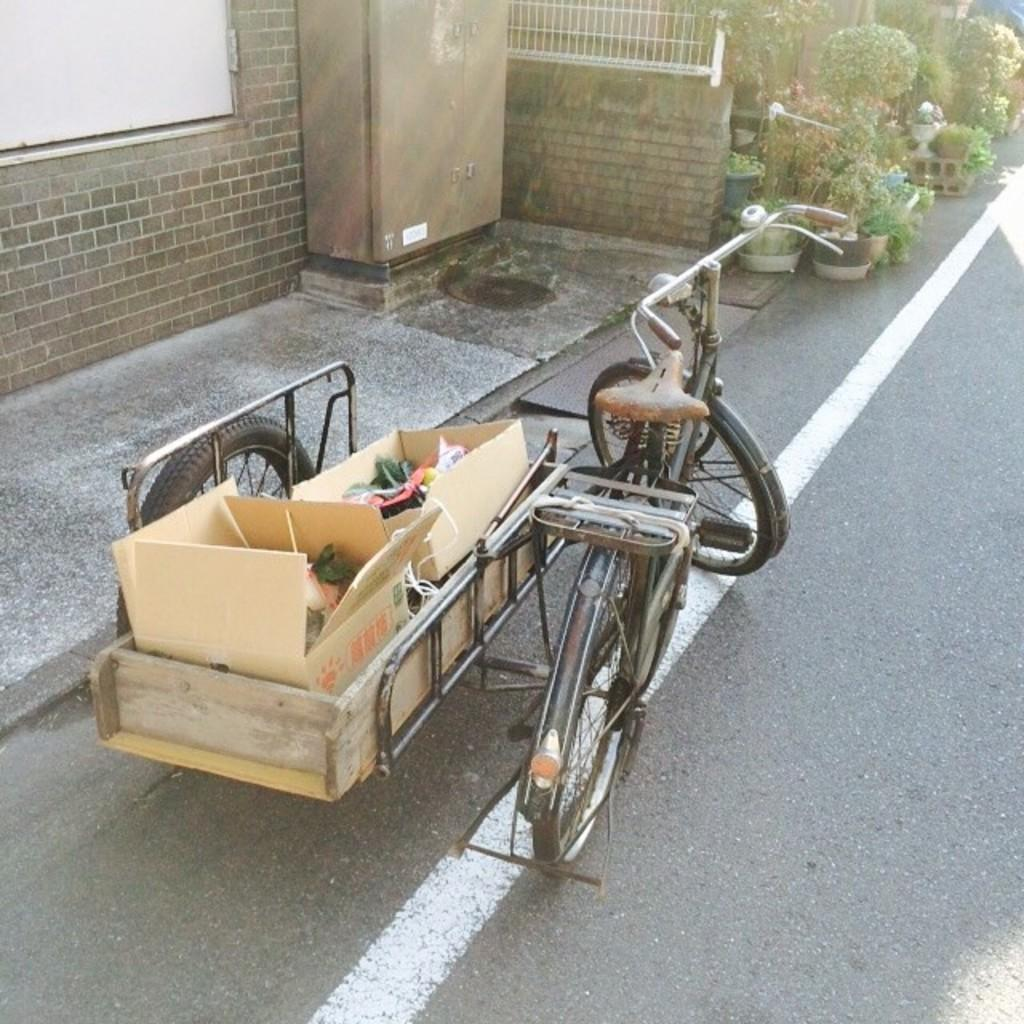What is on the road in the image? There is a bicycle sidecar on the road in the image. What is inside the sidecar? Cardboard boxes are placed inside the sidecar. What can be seen in the background of the image? There is a brick wall and boxes visible in the background of the image. What type of vegetation is present in the background of the image? Flowerpots (flowertots) are present in the background of the image. What type of nose can be seen on the bicycle in the image? There is no nose present on the bicycle or any other object in the image. 